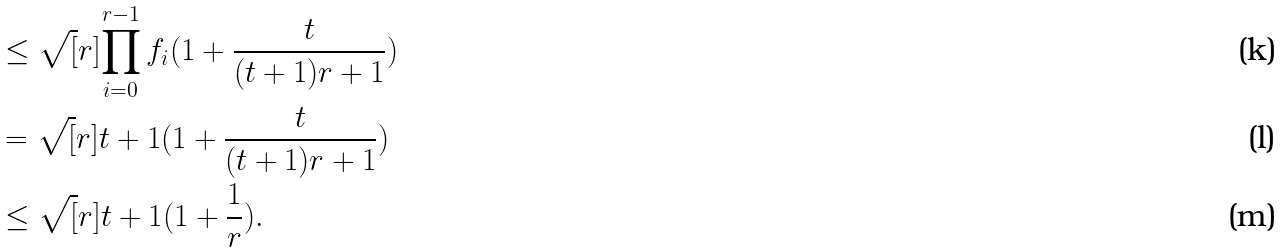<formula> <loc_0><loc_0><loc_500><loc_500>& \leq \sqrt { [ } r ] { \prod _ { i = 0 } ^ { r - 1 } f _ { i } ( 1 + \frac { t } { ( t + 1 ) r + 1 } ) } \\ & = \sqrt { [ } r ] { t + 1 } ( 1 + \frac { t } { ( t + 1 ) r + 1 } ) \\ & \leq \sqrt { [ } r ] { t + 1 } ( 1 + \frac { 1 } { r } ) .</formula> 